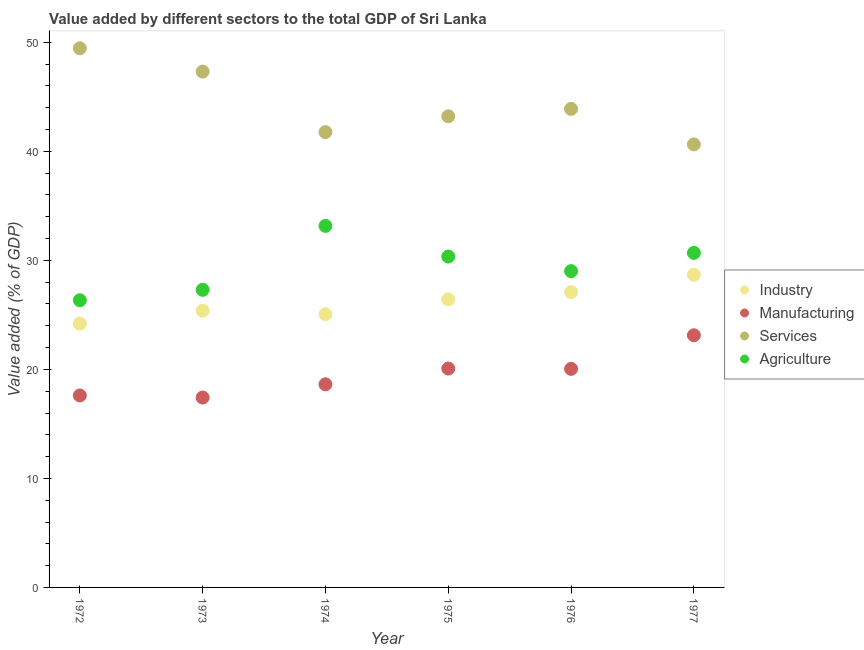How many different coloured dotlines are there?
Provide a short and direct response. 4. What is the value added by industrial sector in 1973?
Your response must be concise. 25.39. Across all years, what is the maximum value added by manufacturing sector?
Provide a succinct answer. 23.13. Across all years, what is the minimum value added by industrial sector?
Ensure brevity in your answer.  24.2. In which year was the value added by industrial sector minimum?
Ensure brevity in your answer.  1972. What is the total value added by industrial sector in the graph?
Your answer should be compact. 156.84. What is the difference between the value added by agricultural sector in 1973 and that in 1974?
Provide a short and direct response. -5.87. What is the difference between the value added by industrial sector in 1974 and the value added by agricultural sector in 1976?
Your answer should be very brief. -3.95. What is the average value added by agricultural sector per year?
Give a very brief answer. 29.48. In the year 1976, what is the difference between the value added by manufacturing sector and value added by agricultural sector?
Your answer should be very brief. -8.96. In how many years, is the value added by services sector greater than 38 %?
Make the answer very short. 6. What is the ratio of the value added by manufacturing sector in 1975 to that in 1977?
Your answer should be very brief. 0.87. Is the difference between the value added by industrial sector in 1973 and 1975 greater than the difference between the value added by services sector in 1973 and 1975?
Your answer should be very brief. No. What is the difference between the highest and the second highest value added by services sector?
Your answer should be very brief. 2.14. What is the difference between the highest and the lowest value added by agricultural sector?
Give a very brief answer. 6.82. Is it the case that in every year, the sum of the value added by services sector and value added by industrial sector is greater than the sum of value added by manufacturing sector and value added by agricultural sector?
Provide a succinct answer. No. Is it the case that in every year, the sum of the value added by industrial sector and value added by manufacturing sector is greater than the value added by services sector?
Your answer should be very brief. No. Is the value added by services sector strictly greater than the value added by agricultural sector over the years?
Give a very brief answer. Yes. How many dotlines are there?
Give a very brief answer. 4. Does the graph contain any zero values?
Your answer should be very brief. No. Does the graph contain grids?
Offer a very short reply. No. Where does the legend appear in the graph?
Provide a succinct answer. Center right. How many legend labels are there?
Make the answer very short. 4. How are the legend labels stacked?
Offer a terse response. Vertical. What is the title of the graph?
Provide a succinct answer. Value added by different sectors to the total GDP of Sri Lanka. What is the label or title of the X-axis?
Offer a very short reply. Year. What is the label or title of the Y-axis?
Offer a very short reply. Value added (% of GDP). What is the Value added (% of GDP) in Industry in 1972?
Your response must be concise. 24.2. What is the Value added (% of GDP) of Manufacturing in 1972?
Provide a short and direct response. 17.61. What is the Value added (% of GDP) of Services in 1972?
Provide a succinct answer. 49.46. What is the Value added (% of GDP) in Agriculture in 1972?
Provide a short and direct response. 26.35. What is the Value added (% of GDP) in Industry in 1973?
Make the answer very short. 25.39. What is the Value added (% of GDP) of Manufacturing in 1973?
Offer a very short reply. 17.42. What is the Value added (% of GDP) in Services in 1973?
Offer a very short reply. 47.32. What is the Value added (% of GDP) of Agriculture in 1973?
Your answer should be compact. 27.3. What is the Value added (% of GDP) in Industry in 1974?
Provide a succinct answer. 25.07. What is the Value added (% of GDP) of Manufacturing in 1974?
Provide a succinct answer. 18.63. What is the Value added (% of GDP) in Services in 1974?
Keep it short and to the point. 41.77. What is the Value added (% of GDP) in Agriculture in 1974?
Offer a very short reply. 33.16. What is the Value added (% of GDP) in Industry in 1975?
Make the answer very short. 26.43. What is the Value added (% of GDP) of Manufacturing in 1975?
Provide a succinct answer. 20.08. What is the Value added (% of GDP) of Services in 1975?
Offer a very short reply. 43.22. What is the Value added (% of GDP) in Agriculture in 1975?
Offer a terse response. 30.35. What is the Value added (% of GDP) of Industry in 1976?
Your answer should be compact. 27.09. What is the Value added (% of GDP) of Manufacturing in 1976?
Your response must be concise. 20.05. What is the Value added (% of GDP) of Services in 1976?
Your answer should be compact. 43.9. What is the Value added (% of GDP) in Agriculture in 1976?
Offer a terse response. 29.01. What is the Value added (% of GDP) of Industry in 1977?
Offer a terse response. 28.67. What is the Value added (% of GDP) of Manufacturing in 1977?
Your response must be concise. 23.13. What is the Value added (% of GDP) of Services in 1977?
Keep it short and to the point. 40.64. What is the Value added (% of GDP) in Agriculture in 1977?
Your response must be concise. 30.69. Across all years, what is the maximum Value added (% of GDP) in Industry?
Make the answer very short. 28.67. Across all years, what is the maximum Value added (% of GDP) in Manufacturing?
Give a very brief answer. 23.13. Across all years, what is the maximum Value added (% of GDP) in Services?
Ensure brevity in your answer.  49.46. Across all years, what is the maximum Value added (% of GDP) of Agriculture?
Your answer should be compact. 33.16. Across all years, what is the minimum Value added (% of GDP) in Industry?
Provide a succinct answer. 24.2. Across all years, what is the minimum Value added (% of GDP) in Manufacturing?
Provide a short and direct response. 17.42. Across all years, what is the minimum Value added (% of GDP) in Services?
Ensure brevity in your answer.  40.64. Across all years, what is the minimum Value added (% of GDP) in Agriculture?
Offer a very short reply. 26.35. What is the total Value added (% of GDP) in Industry in the graph?
Provide a succinct answer. 156.84. What is the total Value added (% of GDP) in Manufacturing in the graph?
Offer a very short reply. 116.92. What is the total Value added (% of GDP) of Services in the graph?
Your answer should be compact. 266.29. What is the total Value added (% of GDP) of Agriculture in the graph?
Keep it short and to the point. 176.86. What is the difference between the Value added (% of GDP) of Industry in 1972 and that in 1973?
Your answer should be very brief. -1.19. What is the difference between the Value added (% of GDP) in Manufacturing in 1972 and that in 1973?
Provide a succinct answer. 0.19. What is the difference between the Value added (% of GDP) in Services in 1972 and that in 1973?
Offer a very short reply. 2.14. What is the difference between the Value added (% of GDP) in Agriculture in 1972 and that in 1973?
Offer a terse response. -0.95. What is the difference between the Value added (% of GDP) in Industry in 1972 and that in 1974?
Keep it short and to the point. -0.87. What is the difference between the Value added (% of GDP) in Manufacturing in 1972 and that in 1974?
Provide a succinct answer. -1.02. What is the difference between the Value added (% of GDP) in Services in 1972 and that in 1974?
Ensure brevity in your answer.  7.69. What is the difference between the Value added (% of GDP) in Agriculture in 1972 and that in 1974?
Make the answer very short. -6.82. What is the difference between the Value added (% of GDP) in Industry in 1972 and that in 1975?
Your response must be concise. -2.23. What is the difference between the Value added (% of GDP) of Manufacturing in 1972 and that in 1975?
Keep it short and to the point. -2.47. What is the difference between the Value added (% of GDP) in Services in 1972 and that in 1975?
Offer a very short reply. 6.24. What is the difference between the Value added (% of GDP) in Agriculture in 1972 and that in 1975?
Offer a very short reply. -4.01. What is the difference between the Value added (% of GDP) in Industry in 1972 and that in 1976?
Make the answer very short. -2.89. What is the difference between the Value added (% of GDP) in Manufacturing in 1972 and that in 1976?
Give a very brief answer. -2.44. What is the difference between the Value added (% of GDP) of Services in 1972 and that in 1976?
Provide a short and direct response. 5.56. What is the difference between the Value added (% of GDP) in Agriculture in 1972 and that in 1976?
Your answer should be very brief. -2.67. What is the difference between the Value added (% of GDP) in Industry in 1972 and that in 1977?
Your answer should be compact. -4.47. What is the difference between the Value added (% of GDP) of Manufacturing in 1972 and that in 1977?
Ensure brevity in your answer.  -5.52. What is the difference between the Value added (% of GDP) in Services in 1972 and that in 1977?
Provide a short and direct response. 8.82. What is the difference between the Value added (% of GDP) in Agriculture in 1972 and that in 1977?
Ensure brevity in your answer.  -4.34. What is the difference between the Value added (% of GDP) in Industry in 1973 and that in 1974?
Make the answer very short. 0.32. What is the difference between the Value added (% of GDP) of Manufacturing in 1973 and that in 1974?
Provide a short and direct response. -1.21. What is the difference between the Value added (% of GDP) of Services in 1973 and that in 1974?
Provide a short and direct response. 5.55. What is the difference between the Value added (% of GDP) of Agriculture in 1973 and that in 1974?
Offer a terse response. -5.87. What is the difference between the Value added (% of GDP) in Industry in 1973 and that in 1975?
Your answer should be very brief. -1.04. What is the difference between the Value added (% of GDP) in Manufacturing in 1973 and that in 1975?
Your response must be concise. -2.66. What is the difference between the Value added (% of GDP) in Services in 1973 and that in 1975?
Give a very brief answer. 4.1. What is the difference between the Value added (% of GDP) in Agriculture in 1973 and that in 1975?
Your response must be concise. -3.05. What is the difference between the Value added (% of GDP) in Industry in 1973 and that in 1976?
Your response must be concise. -1.71. What is the difference between the Value added (% of GDP) of Manufacturing in 1973 and that in 1976?
Your answer should be very brief. -2.63. What is the difference between the Value added (% of GDP) in Services in 1973 and that in 1976?
Provide a short and direct response. 3.42. What is the difference between the Value added (% of GDP) of Agriculture in 1973 and that in 1976?
Provide a short and direct response. -1.71. What is the difference between the Value added (% of GDP) of Industry in 1973 and that in 1977?
Offer a very short reply. -3.29. What is the difference between the Value added (% of GDP) in Manufacturing in 1973 and that in 1977?
Your response must be concise. -5.71. What is the difference between the Value added (% of GDP) in Services in 1973 and that in 1977?
Keep it short and to the point. 6.68. What is the difference between the Value added (% of GDP) in Agriculture in 1973 and that in 1977?
Keep it short and to the point. -3.39. What is the difference between the Value added (% of GDP) in Industry in 1974 and that in 1975?
Provide a succinct answer. -1.36. What is the difference between the Value added (% of GDP) of Manufacturing in 1974 and that in 1975?
Your response must be concise. -1.44. What is the difference between the Value added (% of GDP) of Services in 1974 and that in 1975?
Give a very brief answer. -1.45. What is the difference between the Value added (% of GDP) in Agriculture in 1974 and that in 1975?
Give a very brief answer. 2.81. What is the difference between the Value added (% of GDP) of Industry in 1974 and that in 1976?
Your answer should be compact. -2.02. What is the difference between the Value added (% of GDP) in Manufacturing in 1974 and that in 1976?
Your response must be concise. -1.41. What is the difference between the Value added (% of GDP) of Services in 1974 and that in 1976?
Give a very brief answer. -2.13. What is the difference between the Value added (% of GDP) of Agriculture in 1974 and that in 1976?
Give a very brief answer. 4.15. What is the difference between the Value added (% of GDP) of Industry in 1974 and that in 1977?
Provide a short and direct response. -3.61. What is the difference between the Value added (% of GDP) of Manufacturing in 1974 and that in 1977?
Offer a very short reply. -4.5. What is the difference between the Value added (% of GDP) in Services in 1974 and that in 1977?
Provide a short and direct response. 1.13. What is the difference between the Value added (% of GDP) of Agriculture in 1974 and that in 1977?
Your answer should be compact. 2.48. What is the difference between the Value added (% of GDP) of Industry in 1975 and that in 1976?
Offer a terse response. -0.66. What is the difference between the Value added (% of GDP) of Manufacturing in 1975 and that in 1976?
Offer a very short reply. 0.03. What is the difference between the Value added (% of GDP) of Services in 1975 and that in 1976?
Provide a succinct answer. -0.68. What is the difference between the Value added (% of GDP) in Agriculture in 1975 and that in 1976?
Offer a terse response. 1.34. What is the difference between the Value added (% of GDP) in Industry in 1975 and that in 1977?
Your answer should be very brief. -2.24. What is the difference between the Value added (% of GDP) of Manufacturing in 1975 and that in 1977?
Make the answer very short. -3.05. What is the difference between the Value added (% of GDP) in Services in 1975 and that in 1977?
Your answer should be very brief. 2.58. What is the difference between the Value added (% of GDP) of Agriculture in 1975 and that in 1977?
Ensure brevity in your answer.  -0.34. What is the difference between the Value added (% of GDP) in Industry in 1976 and that in 1977?
Your answer should be compact. -1.58. What is the difference between the Value added (% of GDP) of Manufacturing in 1976 and that in 1977?
Your answer should be very brief. -3.08. What is the difference between the Value added (% of GDP) in Services in 1976 and that in 1977?
Make the answer very short. 3.26. What is the difference between the Value added (% of GDP) of Agriculture in 1976 and that in 1977?
Offer a very short reply. -1.68. What is the difference between the Value added (% of GDP) of Industry in 1972 and the Value added (% of GDP) of Manufacturing in 1973?
Your answer should be very brief. 6.78. What is the difference between the Value added (% of GDP) in Industry in 1972 and the Value added (% of GDP) in Services in 1973?
Provide a short and direct response. -23.12. What is the difference between the Value added (% of GDP) in Industry in 1972 and the Value added (% of GDP) in Agriculture in 1973?
Offer a very short reply. -3.1. What is the difference between the Value added (% of GDP) of Manufacturing in 1972 and the Value added (% of GDP) of Services in 1973?
Your answer should be very brief. -29.71. What is the difference between the Value added (% of GDP) in Manufacturing in 1972 and the Value added (% of GDP) in Agriculture in 1973?
Your response must be concise. -9.69. What is the difference between the Value added (% of GDP) in Services in 1972 and the Value added (% of GDP) in Agriculture in 1973?
Keep it short and to the point. 22.16. What is the difference between the Value added (% of GDP) in Industry in 1972 and the Value added (% of GDP) in Manufacturing in 1974?
Keep it short and to the point. 5.56. What is the difference between the Value added (% of GDP) of Industry in 1972 and the Value added (% of GDP) of Services in 1974?
Keep it short and to the point. -17.57. What is the difference between the Value added (% of GDP) in Industry in 1972 and the Value added (% of GDP) in Agriculture in 1974?
Make the answer very short. -8.97. What is the difference between the Value added (% of GDP) in Manufacturing in 1972 and the Value added (% of GDP) in Services in 1974?
Offer a very short reply. -24.16. What is the difference between the Value added (% of GDP) in Manufacturing in 1972 and the Value added (% of GDP) in Agriculture in 1974?
Offer a terse response. -15.56. What is the difference between the Value added (% of GDP) in Services in 1972 and the Value added (% of GDP) in Agriculture in 1974?
Keep it short and to the point. 16.29. What is the difference between the Value added (% of GDP) in Industry in 1972 and the Value added (% of GDP) in Manufacturing in 1975?
Your response must be concise. 4.12. What is the difference between the Value added (% of GDP) in Industry in 1972 and the Value added (% of GDP) in Services in 1975?
Keep it short and to the point. -19.02. What is the difference between the Value added (% of GDP) in Industry in 1972 and the Value added (% of GDP) in Agriculture in 1975?
Provide a succinct answer. -6.15. What is the difference between the Value added (% of GDP) of Manufacturing in 1972 and the Value added (% of GDP) of Services in 1975?
Ensure brevity in your answer.  -25.61. What is the difference between the Value added (% of GDP) of Manufacturing in 1972 and the Value added (% of GDP) of Agriculture in 1975?
Offer a very short reply. -12.74. What is the difference between the Value added (% of GDP) in Services in 1972 and the Value added (% of GDP) in Agriculture in 1975?
Offer a very short reply. 19.1. What is the difference between the Value added (% of GDP) in Industry in 1972 and the Value added (% of GDP) in Manufacturing in 1976?
Your answer should be very brief. 4.15. What is the difference between the Value added (% of GDP) of Industry in 1972 and the Value added (% of GDP) of Services in 1976?
Offer a very short reply. -19.7. What is the difference between the Value added (% of GDP) of Industry in 1972 and the Value added (% of GDP) of Agriculture in 1976?
Give a very brief answer. -4.81. What is the difference between the Value added (% of GDP) of Manufacturing in 1972 and the Value added (% of GDP) of Services in 1976?
Give a very brief answer. -26.29. What is the difference between the Value added (% of GDP) of Manufacturing in 1972 and the Value added (% of GDP) of Agriculture in 1976?
Provide a short and direct response. -11.4. What is the difference between the Value added (% of GDP) in Services in 1972 and the Value added (% of GDP) in Agriculture in 1976?
Make the answer very short. 20.44. What is the difference between the Value added (% of GDP) in Industry in 1972 and the Value added (% of GDP) in Manufacturing in 1977?
Keep it short and to the point. 1.07. What is the difference between the Value added (% of GDP) in Industry in 1972 and the Value added (% of GDP) in Services in 1977?
Your answer should be compact. -16.44. What is the difference between the Value added (% of GDP) in Industry in 1972 and the Value added (% of GDP) in Agriculture in 1977?
Your answer should be very brief. -6.49. What is the difference between the Value added (% of GDP) of Manufacturing in 1972 and the Value added (% of GDP) of Services in 1977?
Keep it short and to the point. -23.03. What is the difference between the Value added (% of GDP) of Manufacturing in 1972 and the Value added (% of GDP) of Agriculture in 1977?
Your response must be concise. -13.08. What is the difference between the Value added (% of GDP) of Services in 1972 and the Value added (% of GDP) of Agriculture in 1977?
Provide a succinct answer. 18.77. What is the difference between the Value added (% of GDP) in Industry in 1973 and the Value added (% of GDP) in Manufacturing in 1974?
Provide a short and direct response. 6.75. What is the difference between the Value added (% of GDP) in Industry in 1973 and the Value added (% of GDP) in Services in 1974?
Your answer should be very brief. -16.38. What is the difference between the Value added (% of GDP) of Industry in 1973 and the Value added (% of GDP) of Agriculture in 1974?
Your response must be concise. -7.78. What is the difference between the Value added (% of GDP) in Manufacturing in 1973 and the Value added (% of GDP) in Services in 1974?
Your answer should be very brief. -24.35. What is the difference between the Value added (% of GDP) in Manufacturing in 1973 and the Value added (% of GDP) in Agriculture in 1974?
Keep it short and to the point. -15.74. What is the difference between the Value added (% of GDP) in Services in 1973 and the Value added (% of GDP) in Agriculture in 1974?
Your answer should be compact. 14.15. What is the difference between the Value added (% of GDP) in Industry in 1973 and the Value added (% of GDP) in Manufacturing in 1975?
Offer a very short reply. 5.31. What is the difference between the Value added (% of GDP) in Industry in 1973 and the Value added (% of GDP) in Services in 1975?
Your answer should be very brief. -17.83. What is the difference between the Value added (% of GDP) of Industry in 1973 and the Value added (% of GDP) of Agriculture in 1975?
Your answer should be very brief. -4.97. What is the difference between the Value added (% of GDP) in Manufacturing in 1973 and the Value added (% of GDP) in Services in 1975?
Ensure brevity in your answer.  -25.8. What is the difference between the Value added (% of GDP) of Manufacturing in 1973 and the Value added (% of GDP) of Agriculture in 1975?
Provide a short and direct response. -12.93. What is the difference between the Value added (% of GDP) in Services in 1973 and the Value added (% of GDP) in Agriculture in 1975?
Ensure brevity in your answer.  16.96. What is the difference between the Value added (% of GDP) in Industry in 1973 and the Value added (% of GDP) in Manufacturing in 1976?
Your answer should be very brief. 5.34. What is the difference between the Value added (% of GDP) of Industry in 1973 and the Value added (% of GDP) of Services in 1976?
Your answer should be compact. -18.51. What is the difference between the Value added (% of GDP) of Industry in 1973 and the Value added (% of GDP) of Agriculture in 1976?
Provide a succinct answer. -3.63. What is the difference between the Value added (% of GDP) in Manufacturing in 1973 and the Value added (% of GDP) in Services in 1976?
Keep it short and to the point. -26.47. What is the difference between the Value added (% of GDP) in Manufacturing in 1973 and the Value added (% of GDP) in Agriculture in 1976?
Provide a short and direct response. -11.59. What is the difference between the Value added (% of GDP) of Services in 1973 and the Value added (% of GDP) of Agriculture in 1976?
Your answer should be compact. 18.3. What is the difference between the Value added (% of GDP) of Industry in 1973 and the Value added (% of GDP) of Manufacturing in 1977?
Offer a terse response. 2.25. What is the difference between the Value added (% of GDP) in Industry in 1973 and the Value added (% of GDP) in Services in 1977?
Provide a short and direct response. -15.25. What is the difference between the Value added (% of GDP) of Industry in 1973 and the Value added (% of GDP) of Agriculture in 1977?
Keep it short and to the point. -5.3. What is the difference between the Value added (% of GDP) of Manufacturing in 1973 and the Value added (% of GDP) of Services in 1977?
Offer a terse response. -23.22. What is the difference between the Value added (% of GDP) in Manufacturing in 1973 and the Value added (% of GDP) in Agriculture in 1977?
Your answer should be very brief. -13.27. What is the difference between the Value added (% of GDP) of Services in 1973 and the Value added (% of GDP) of Agriculture in 1977?
Make the answer very short. 16.63. What is the difference between the Value added (% of GDP) of Industry in 1974 and the Value added (% of GDP) of Manufacturing in 1975?
Provide a short and direct response. 4.99. What is the difference between the Value added (% of GDP) of Industry in 1974 and the Value added (% of GDP) of Services in 1975?
Give a very brief answer. -18.15. What is the difference between the Value added (% of GDP) of Industry in 1974 and the Value added (% of GDP) of Agriculture in 1975?
Your answer should be very brief. -5.29. What is the difference between the Value added (% of GDP) of Manufacturing in 1974 and the Value added (% of GDP) of Services in 1975?
Keep it short and to the point. -24.58. What is the difference between the Value added (% of GDP) of Manufacturing in 1974 and the Value added (% of GDP) of Agriculture in 1975?
Offer a very short reply. -11.72. What is the difference between the Value added (% of GDP) of Services in 1974 and the Value added (% of GDP) of Agriculture in 1975?
Keep it short and to the point. 11.42. What is the difference between the Value added (% of GDP) in Industry in 1974 and the Value added (% of GDP) in Manufacturing in 1976?
Give a very brief answer. 5.02. What is the difference between the Value added (% of GDP) in Industry in 1974 and the Value added (% of GDP) in Services in 1976?
Offer a very short reply. -18.83. What is the difference between the Value added (% of GDP) in Industry in 1974 and the Value added (% of GDP) in Agriculture in 1976?
Offer a terse response. -3.95. What is the difference between the Value added (% of GDP) in Manufacturing in 1974 and the Value added (% of GDP) in Services in 1976?
Give a very brief answer. -25.26. What is the difference between the Value added (% of GDP) in Manufacturing in 1974 and the Value added (% of GDP) in Agriculture in 1976?
Give a very brief answer. -10.38. What is the difference between the Value added (% of GDP) in Services in 1974 and the Value added (% of GDP) in Agriculture in 1976?
Your answer should be compact. 12.76. What is the difference between the Value added (% of GDP) in Industry in 1974 and the Value added (% of GDP) in Manufacturing in 1977?
Your answer should be very brief. 1.93. What is the difference between the Value added (% of GDP) in Industry in 1974 and the Value added (% of GDP) in Services in 1977?
Offer a very short reply. -15.57. What is the difference between the Value added (% of GDP) in Industry in 1974 and the Value added (% of GDP) in Agriculture in 1977?
Offer a very short reply. -5.62. What is the difference between the Value added (% of GDP) in Manufacturing in 1974 and the Value added (% of GDP) in Services in 1977?
Your answer should be compact. -22. What is the difference between the Value added (% of GDP) in Manufacturing in 1974 and the Value added (% of GDP) in Agriculture in 1977?
Your answer should be compact. -12.05. What is the difference between the Value added (% of GDP) of Services in 1974 and the Value added (% of GDP) of Agriculture in 1977?
Provide a succinct answer. 11.08. What is the difference between the Value added (% of GDP) of Industry in 1975 and the Value added (% of GDP) of Manufacturing in 1976?
Offer a terse response. 6.38. What is the difference between the Value added (% of GDP) in Industry in 1975 and the Value added (% of GDP) in Services in 1976?
Your answer should be compact. -17.47. What is the difference between the Value added (% of GDP) in Industry in 1975 and the Value added (% of GDP) in Agriculture in 1976?
Your answer should be compact. -2.58. What is the difference between the Value added (% of GDP) in Manufacturing in 1975 and the Value added (% of GDP) in Services in 1976?
Offer a very short reply. -23.82. What is the difference between the Value added (% of GDP) of Manufacturing in 1975 and the Value added (% of GDP) of Agriculture in 1976?
Offer a very short reply. -8.94. What is the difference between the Value added (% of GDP) in Services in 1975 and the Value added (% of GDP) in Agriculture in 1976?
Your answer should be compact. 14.2. What is the difference between the Value added (% of GDP) of Industry in 1975 and the Value added (% of GDP) of Manufacturing in 1977?
Make the answer very short. 3.3. What is the difference between the Value added (% of GDP) in Industry in 1975 and the Value added (% of GDP) in Services in 1977?
Provide a short and direct response. -14.21. What is the difference between the Value added (% of GDP) in Industry in 1975 and the Value added (% of GDP) in Agriculture in 1977?
Offer a very short reply. -4.26. What is the difference between the Value added (% of GDP) of Manufacturing in 1975 and the Value added (% of GDP) of Services in 1977?
Offer a terse response. -20.56. What is the difference between the Value added (% of GDP) of Manufacturing in 1975 and the Value added (% of GDP) of Agriculture in 1977?
Make the answer very short. -10.61. What is the difference between the Value added (% of GDP) in Services in 1975 and the Value added (% of GDP) in Agriculture in 1977?
Keep it short and to the point. 12.53. What is the difference between the Value added (% of GDP) in Industry in 1976 and the Value added (% of GDP) in Manufacturing in 1977?
Keep it short and to the point. 3.96. What is the difference between the Value added (% of GDP) in Industry in 1976 and the Value added (% of GDP) in Services in 1977?
Your answer should be compact. -13.55. What is the difference between the Value added (% of GDP) in Industry in 1976 and the Value added (% of GDP) in Agriculture in 1977?
Provide a succinct answer. -3.6. What is the difference between the Value added (% of GDP) of Manufacturing in 1976 and the Value added (% of GDP) of Services in 1977?
Offer a very short reply. -20.59. What is the difference between the Value added (% of GDP) in Manufacturing in 1976 and the Value added (% of GDP) in Agriculture in 1977?
Ensure brevity in your answer.  -10.64. What is the difference between the Value added (% of GDP) in Services in 1976 and the Value added (% of GDP) in Agriculture in 1977?
Your response must be concise. 13.21. What is the average Value added (% of GDP) of Industry per year?
Give a very brief answer. 26.14. What is the average Value added (% of GDP) of Manufacturing per year?
Ensure brevity in your answer.  19.49. What is the average Value added (% of GDP) in Services per year?
Offer a terse response. 44.38. What is the average Value added (% of GDP) in Agriculture per year?
Your answer should be compact. 29.48. In the year 1972, what is the difference between the Value added (% of GDP) of Industry and Value added (% of GDP) of Manufacturing?
Your answer should be very brief. 6.59. In the year 1972, what is the difference between the Value added (% of GDP) in Industry and Value added (% of GDP) in Services?
Your answer should be very brief. -25.26. In the year 1972, what is the difference between the Value added (% of GDP) in Industry and Value added (% of GDP) in Agriculture?
Keep it short and to the point. -2.15. In the year 1972, what is the difference between the Value added (% of GDP) in Manufacturing and Value added (% of GDP) in Services?
Keep it short and to the point. -31.85. In the year 1972, what is the difference between the Value added (% of GDP) of Manufacturing and Value added (% of GDP) of Agriculture?
Offer a terse response. -8.74. In the year 1972, what is the difference between the Value added (% of GDP) of Services and Value added (% of GDP) of Agriculture?
Keep it short and to the point. 23.11. In the year 1973, what is the difference between the Value added (% of GDP) in Industry and Value added (% of GDP) in Manufacturing?
Your answer should be very brief. 7.96. In the year 1973, what is the difference between the Value added (% of GDP) of Industry and Value added (% of GDP) of Services?
Make the answer very short. -21.93. In the year 1973, what is the difference between the Value added (% of GDP) in Industry and Value added (% of GDP) in Agriculture?
Ensure brevity in your answer.  -1.91. In the year 1973, what is the difference between the Value added (% of GDP) in Manufacturing and Value added (% of GDP) in Services?
Your answer should be very brief. -29.89. In the year 1973, what is the difference between the Value added (% of GDP) of Manufacturing and Value added (% of GDP) of Agriculture?
Offer a very short reply. -9.88. In the year 1973, what is the difference between the Value added (% of GDP) in Services and Value added (% of GDP) in Agriculture?
Your response must be concise. 20.02. In the year 1974, what is the difference between the Value added (% of GDP) in Industry and Value added (% of GDP) in Manufacturing?
Provide a short and direct response. 6.43. In the year 1974, what is the difference between the Value added (% of GDP) of Industry and Value added (% of GDP) of Services?
Ensure brevity in your answer.  -16.7. In the year 1974, what is the difference between the Value added (% of GDP) in Industry and Value added (% of GDP) in Agriculture?
Your answer should be compact. -8.1. In the year 1974, what is the difference between the Value added (% of GDP) of Manufacturing and Value added (% of GDP) of Services?
Offer a terse response. -23.14. In the year 1974, what is the difference between the Value added (% of GDP) of Manufacturing and Value added (% of GDP) of Agriculture?
Provide a short and direct response. -14.53. In the year 1974, what is the difference between the Value added (% of GDP) of Services and Value added (% of GDP) of Agriculture?
Offer a very short reply. 8.6. In the year 1975, what is the difference between the Value added (% of GDP) in Industry and Value added (% of GDP) in Manufacturing?
Provide a short and direct response. 6.35. In the year 1975, what is the difference between the Value added (% of GDP) of Industry and Value added (% of GDP) of Services?
Provide a short and direct response. -16.79. In the year 1975, what is the difference between the Value added (% of GDP) in Industry and Value added (% of GDP) in Agriculture?
Offer a very short reply. -3.92. In the year 1975, what is the difference between the Value added (% of GDP) of Manufacturing and Value added (% of GDP) of Services?
Your answer should be very brief. -23.14. In the year 1975, what is the difference between the Value added (% of GDP) in Manufacturing and Value added (% of GDP) in Agriculture?
Offer a terse response. -10.28. In the year 1975, what is the difference between the Value added (% of GDP) of Services and Value added (% of GDP) of Agriculture?
Your answer should be very brief. 12.86. In the year 1976, what is the difference between the Value added (% of GDP) in Industry and Value added (% of GDP) in Manufacturing?
Offer a very short reply. 7.04. In the year 1976, what is the difference between the Value added (% of GDP) of Industry and Value added (% of GDP) of Services?
Ensure brevity in your answer.  -16.81. In the year 1976, what is the difference between the Value added (% of GDP) of Industry and Value added (% of GDP) of Agriculture?
Keep it short and to the point. -1.92. In the year 1976, what is the difference between the Value added (% of GDP) in Manufacturing and Value added (% of GDP) in Services?
Offer a terse response. -23.85. In the year 1976, what is the difference between the Value added (% of GDP) in Manufacturing and Value added (% of GDP) in Agriculture?
Offer a terse response. -8.96. In the year 1976, what is the difference between the Value added (% of GDP) of Services and Value added (% of GDP) of Agriculture?
Your answer should be compact. 14.88. In the year 1977, what is the difference between the Value added (% of GDP) of Industry and Value added (% of GDP) of Manufacturing?
Provide a short and direct response. 5.54. In the year 1977, what is the difference between the Value added (% of GDP) of Industry and Value added (% of GDP) of Services?
Offer a terse response. -11.97. In the year 1977, what is the difference between the Value added (% of GDP) of Industry and Value added (% of GDP) of Agriculture?
Provide a short and direct response. -2.02. In the year 1977, what is the difference between the Value added (% of GDP) in Manufacturing and Value added (% of GDP) in Services?
Keep it short and to the point. -17.51. In the year 1977, what is the difference between the Value added (% of GDP) in Manufacturing and Value added (% of GDP) in Agriculture?
Your answer should be very brief. -7.56. In the year 1977, what is the difference between the Value added (% of GDP) of Services and Value added (% of GDP) of Agriculture?
Make the answer very short. 9.95. What is the ratio of the Value added (% of GDP) of Industry in 1972 to that in 1973?
Give a very brief answer. 0.95. What is the ratio of the Value added (% of GDP) of Manufacturing in 1972 to that in 1973?
Offer a very short reply. 1.01. What is the ratio of the Value added (% of GDP) in Services in 1972 to that in 1973?
Offer a terse response. 1.05. What is the ratio of the Value added (% of GDP) of Agriculture in 1972 to that in 1973?
Keep it short and to the point. 0.97. What is the ratio of the Value added (% of GDP) of Industry in 1972 to that in 1974?
Your response must be concise. 0.97. What is the ratio of the Value added (% of GDP) in Manufacturing in 1972 to that in 1974?
Provide a short and direct response. 0.94. What is the ratio of the Value added (% of GDP) of Services in 1972 to that in 1974?
Your answer should be compact. 1.18. What is the ratio of the Value added (% of GDP) of Agriculture in 1972 to that in 1974?
Offer a terse response. 0.79. What is the ratio of the Value added (% of GDP) in Industry in 1972 to that in 1975?
Your answer should be very brief. 0.92. What is the ratio of the Value added (% of GDP) in Manufacturing in 1972 to that in 1975?
Offer a terse response. 0.88. What is the ratio of the Value added (% of GDP) of Services in 1972 to that in 1975?
Ensure brevity in your answer.  1.14. What is the ratio of the Value added (% of GDP) in Agriculture in 1972 to that in 1975?
Your answer should be very brief. 0.87. What is the ratio of the Value added (% of GDP) of Industry in 1972 to that in 1976?
Provide a succinct answer. 0.89. What is the ratio of the Value added (% of GDP) of Manufacturing in 1972 to that in 1976?
Your response must be concise. 0.88. What is the ratio of the Value added (% of GDP) in Services in 1972 to that in 1976?
Make the answer very short. 1.13. What is the ratio of the Value added (% of GDP) of Agriculture in 1972 to that in 1976?
Your answer should be compact. 0.91. What is the ratio of the Value added (% of GDP) in Industry in 1972 to that in 1977?
Your answer should be compact. 0.84. What is the ratio of the Value added (% of GDP) of Manufacturing in 1972 to that in 1977?
Your answer should be very brief. 0.76. What is the ratio of the Value added (% of GDP) in Services in 1972 to that in 1977?
Make the answer very short. 1.22. What is the ratio of the Value added (% of GDP) of Agriculture in 1972 to that in 1977?
Make the answer very short. 0.86. What is the ratio of the Value added (% of GDP) in Industry in 1973 to that in 1974?
Offer a very short reply. 1.01. What is the ratio of the Value added (% of GDP) in Manufacturing in 1973 to that in 1974?
Offer a very short reply. 0.94. What is the ratio of the Value added (% of GDP) in Services in 1973 to that in 1974?
Ensure brevity in your answer.  1.13. What is the ratio of the Value added (% of GDP) in Agriculture in 1973 to that in 1974?
Ensure brevity in your answer.  0.82. What is the ratio of the Value added (% of GDP) of Industry in 1973 to that in 1975?
Provide a short and direct response. 0.96. What is the ratio of the Value added (% of GDP) in Manufacturing in 1973 to that in 1975?
Your answer should be compact. 0.87. What is the ratio of the Value added (% of GDP) in Services in 1973 to that in 1975?
Provide a succinct answer. 1.09. What is the ratio of the Value added (% of GDP) in Agriculture in 1973 to that in 1975?
Make the answer very short. 0.9. What is the ratio of the Value added (% of GDP) in Industry in 1973 to that in 1976?
Your response must be concise. 0.94. What is the ratio of the Value added (% of GDP) of Manufacturing in 1973 to that in 1976?
Make the answer very short. 0.87. What is the ratio of the Value added (% of GDP) in Services in 1973 to that in 1976?
Provide a succinct answer. 1.08. What is the ratio of the Value added (% of GDP) of Agriculture in 1973 to that in 1976?
Provide a succinct answer. 0.94. What is the ratio of the Value added (% of GDP) in Industry in 1973 to that in 1977?
Give a very brief answer. 0.89. What is the ratio of the Value added (% of GDP) in Manufacturing in 1973 to that in 1977?
Provide a succinct answer. 0.75. What is the ratio of the Value added (% of GDP) in Services in 1973 to that in 1977?
Your answer should be very brief. 1.16. What is the ratio of the Value added (% of GDP) of Agriculture in 1973 to that in 1977?
Keep it short and to the point. 0.89. What is the ratio of the Value added (% of GDP) of Industry in 1974 to that in 1975?
Offer a very short reply. 0.95. What is the ratio of the Value added (% of GDP) in Manufacturing in 1974 to that in 1975?
Your answer should be compact. 0.93. What is the ratio of the Value added (% of GDP) in Services in 1974 to that in 1975?
Make the answer very short. 0.97. What is the ratio of the Value added (% of GDP) of Agriculture in 1974 to that in 1975?
Offer a terse response. 1.09. What is the ratio of the Value added (% of GDP) of Industry in 1974 to that in 1976?
Make the answer very short. 0.93. What is the ratio of the Value added (% of GDP) of Manufacturing in 1974 to that in 1976?
Your response must be concise. 0.93. What is the ratio of the Value added (% of GDP) in Services in 1974 to that in 1976?
Provide a succinct answer. 0.95. What is the ratio of the Value added (% of GDP) in Agriculture in 1974 to that in 1976?
Ensure brevity in your answer.  1.14. What is the ratio of the Value added (% of GDP) in Industry in 1974 to that in 1977?
Provide a short and direct response. 0.87. What is the ratio of the Value added (% of GDP) in Manufacturing in 1974 to that in 1977?
Your answer should be compact. 0.81. What is the ratio of the Value added (% of GDP) of Services in 1974 to that in 1977?
Your answer should be very brief. 1.03. What is the ratio of the Value added (% of GDP) of Agriculture in 1974 to that in 1977?
Give a very brief answer. 1.08. What is the ratio of the Value added (% of GDP) in Industry in 1975 to that in 1976?
Give a very brief answer. 0.98. What is the ratio of the Value added (% of GDP) of Manufacturing in 1975 to that in 1976?
Keep it short and to the point. 1. What is the ratio of the Value added (% of GDP) in Services in 1975 to that in 1976?
Offer a very short reply. 0.98. What is the ratio of the Value added (% of GDP) in Agriculture in 1975 to that in 1976?
Keep it short and to the point. 1.05. What is the ratio of the Value added (% of GDP) of Industry in 1975 to that in 1977?
Provide a short and direct response. 0.92. What is the ratio of the Value added (% of GDP) of Manufacturing in 1975 to that in 1977?
Offer a very short reply. 0.87. What is the ratio of the Value added (% of GDP) of Services in 1975 to that in 1977?
Your answer should be very brief. 1.06. What is the ratio of the Value added (% of GDP) in Agriculture in 1975 to that in 1977?
Provide a succinct answer. 0.99. What is the ratio of the Value added (% of GDP) of Industry in 1976 to that in 1977?
Offer a terse response. 0.94. What is the ratio of the Value added (% of GDP) of Manufacturing in 1976 to that in 1977?
Provide a short and direct response. 0.87. What is the ratio of the Value added (% of GDP) of Services in 1976 to that in 1977?
Your answer should be very brief. 1.08. What is the ratio of the Value added (% of GDP) of Agriculture in 1976 to that in 1977?
Keep it short and to the point. 0.95. What is the difference between the highest and the second highest Value added (% of GDP) in Industry?
Your answer should be compact. 1.58. What is the difference between the highest and the second highest Value added (% of GDP) of Manufacturing?
Ensure brevity in your answer.  3.05. What is the difference between the highest and the second highest Value added (% of GDP) of Services?
Provide a succinct answer. 2.14. What is the difference between the highest and the second highest Value added (% of GDP) of Agriculture?
Your answer should be very brief. 2.48. What is the difference between the highest and the lowest Value added (% of GDP) in Industry?
Ensure brevity in your answer.  4.47. What is the difference between the highest and the lowest Value added (% of GDP) in Manufacturing?
Make the answer very short. 5.71. What is the difference between the highest and the lowest Value added (% of GDP) of Services?
Offer a very short reply. 8.82. What is the difference between the highest and the lowest Value added (% of GDP) in Agriculture?
Your response must be concise. 6.82. 